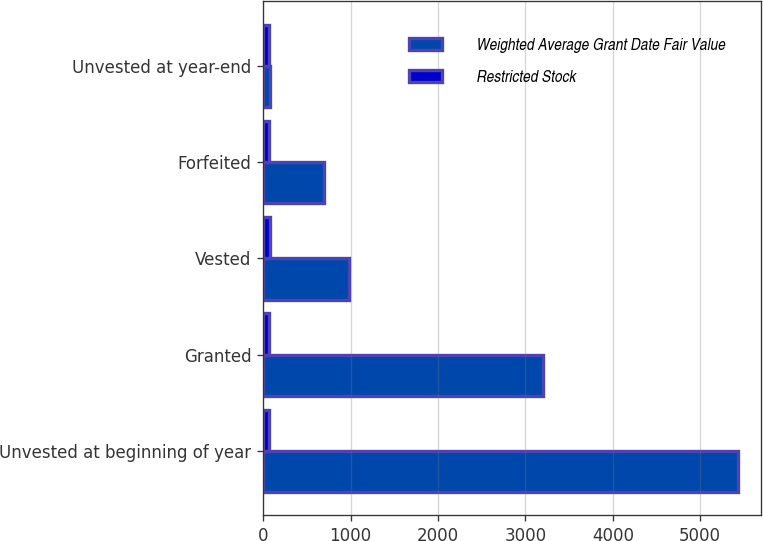<chart> <loc_0><loc_0><loc_500><loc_500><stacked_bar_chart><ecel><fcel>Unvested at beginning of year<fcel>Granted<fcel>Vested<fcel>Forfeited<fcel>Unvested at year-end<nl><fcel>Weighted Average Grant Date Fair Value<fcel>5428<fcel>3204<fcel>982<fcel>699<fcel>77.62<nl><fcel>Restricted Stock<fcel>72.33<fcel>70.54<fcel>77.62<fcel>70.67<fcel>70.13<nl></chart> 